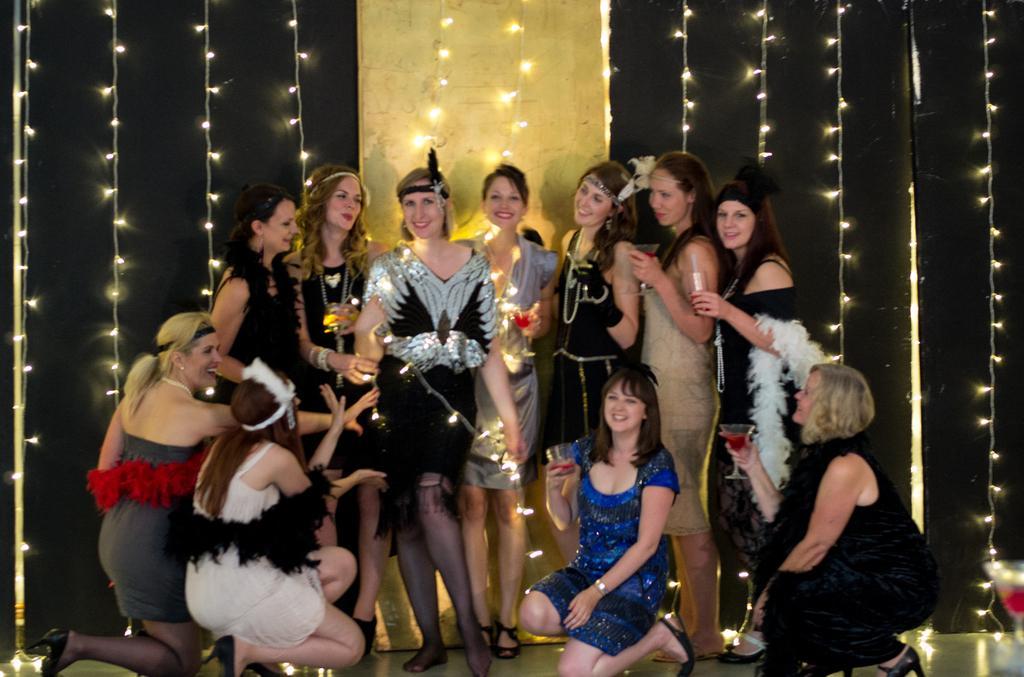In one or two sentences, can you explain what this image depicts? In this image there are group of girls sitting and standing on the stage in which some of them holding glasses behind them there is a wall with lights. 